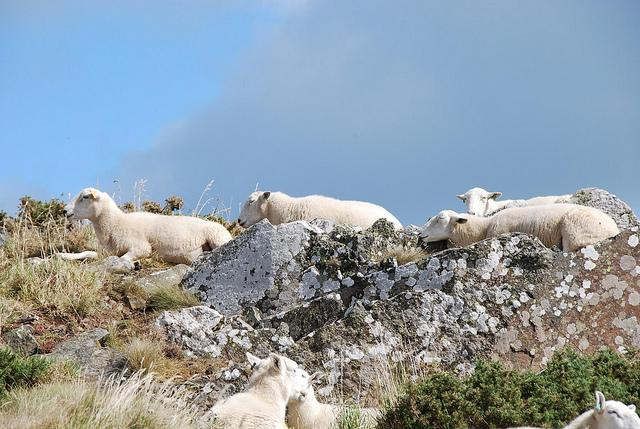What are the animals doing on the hill? Please explain your reasoning. sitting. The animals are lying down. they are not doing anything else. 